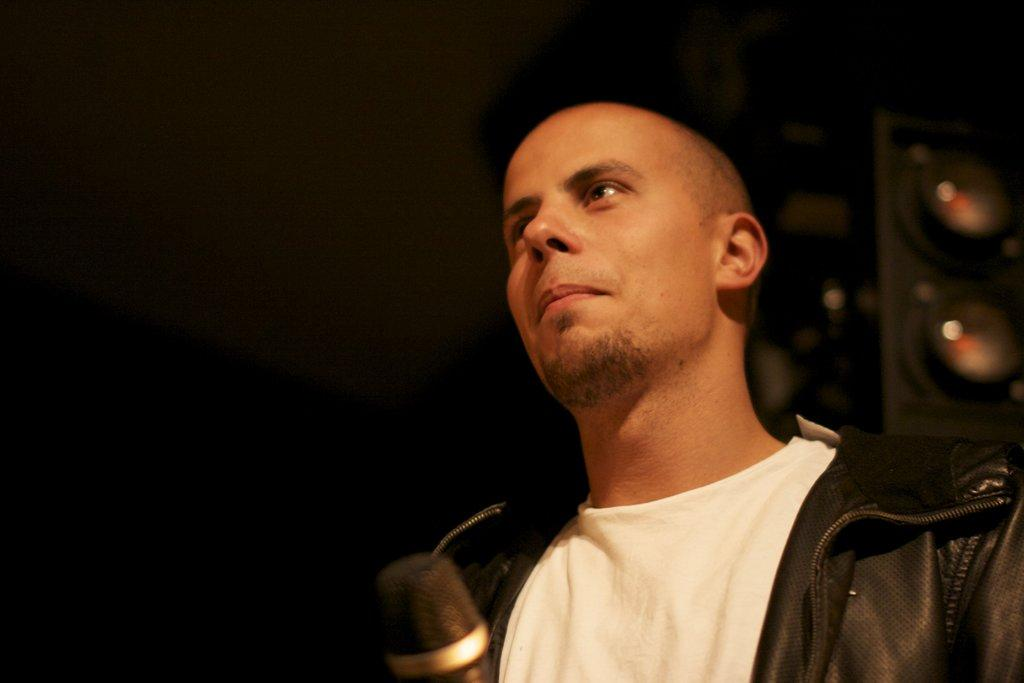What is the main subject of the image? The main subject of the image is a man. Can you describe the man's appearance? The man is wearing clothes and smiling. What object is present in the image that is typically used for amplifying sound? There is a microphone in the image. What is the color of the background in the image? The background of the image is dark. What type of teeth can be seen in the image? There are no teeth visible in the image, as it features a man with a smile and a microphone, but no teeth are shown. 